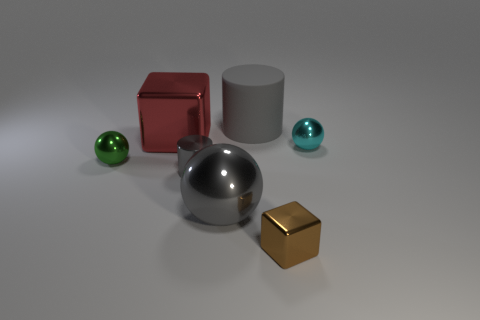Add 2 small brown metal blocks. How many objects exist? 9 Subtract all cylinders. How many objects are left? 5 Subtract all small shiny cylinders. Subtract all small balls. How many objects are left? 4 Add 2 spheres. How many spheres are left? 5 Add 6 large red shiny blocks. How many large red shiny blocks exist? 7 Subtract 1 green spheres. How many objects are left? 6 